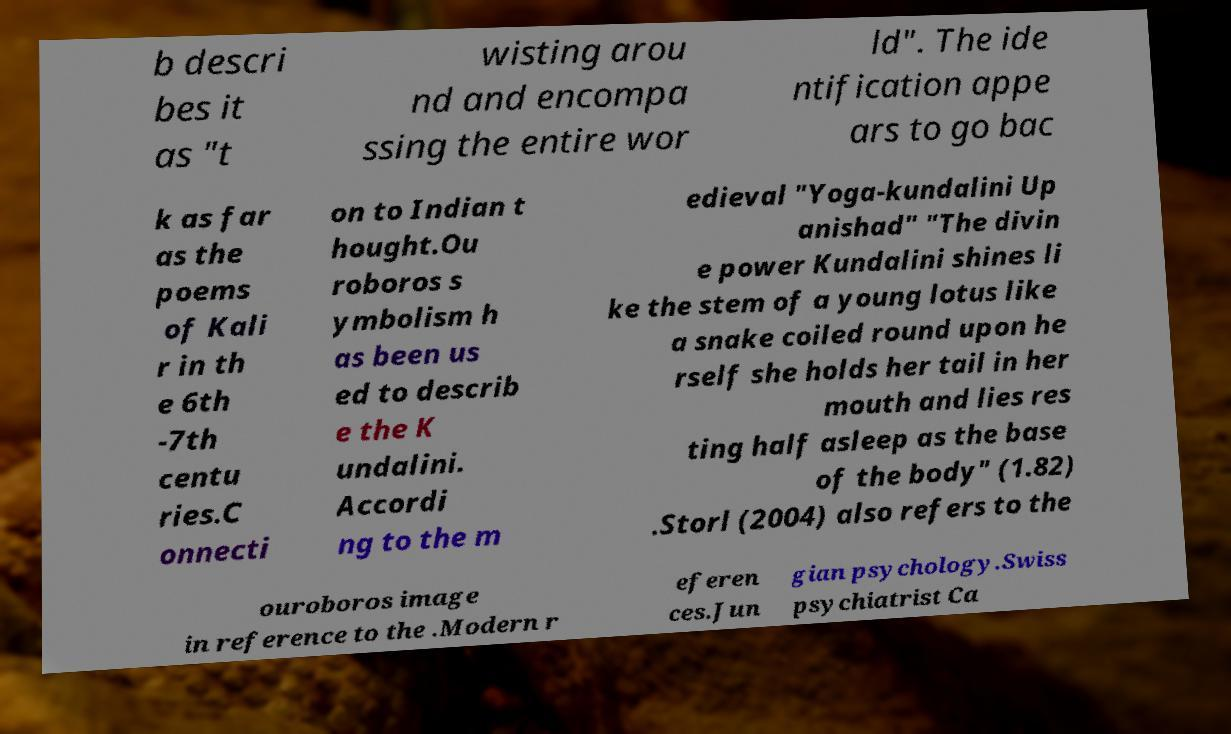Can you read and provide the text displayed in the image?This photo seems to have some interesting text. Can you extract and type it out for me? b descri bes it as "t wisting arou nd and encompa ssing the entire wor ld". The ide ntification appe ars to go bac k as far as the poems of Kali r in th e 6th -7th centu ries.C onnecti on to Indian t hought.Ou roboros s ymbolism h as been us ed to describ e the K undalini. Accordi ng to the m edieval "Yoga-kundalini Up anishad" "The divin e power Kundalini shines li ke the stem of a young lotus like a snake coiled round upon he rself she holds her tail in her mouth and lies res ting half asleep as the base of the body" (1.82) .Storl (2004) also refers to the ouroboros image in reference to the .Modern r eferen ces.Jun gian psychology.Swiss psychiatrist Ca 